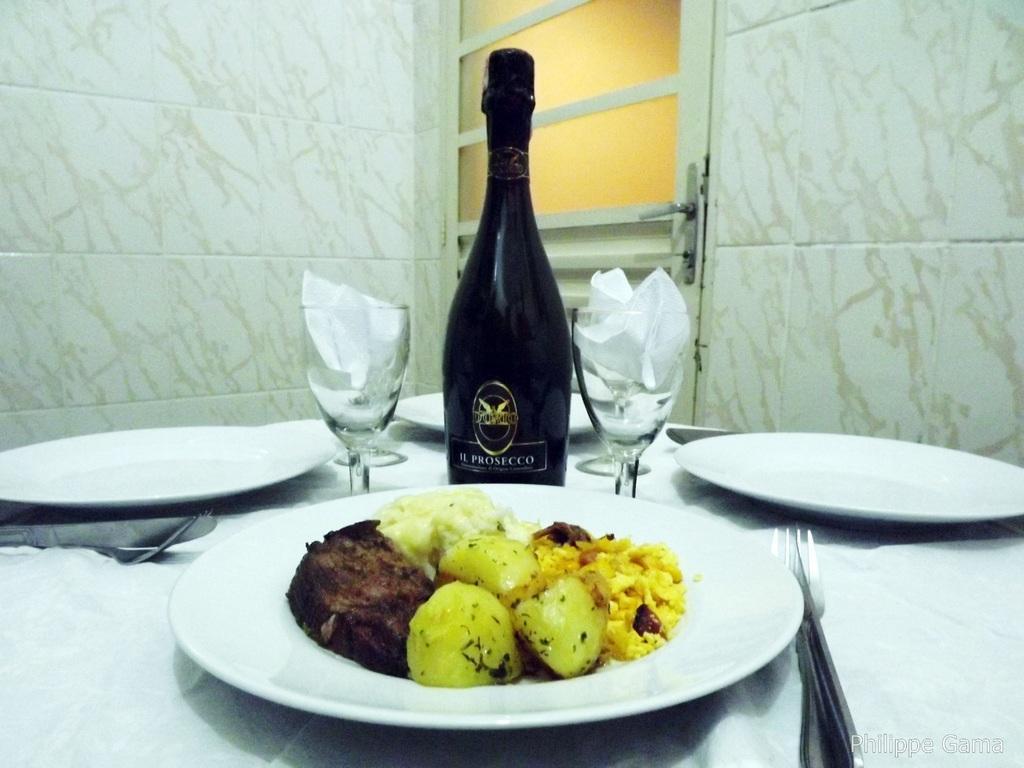Describe this image in one or two sentences. In this image there is a table on that table there are plants, in one plate there is food item and there are glasses and a champagne bottle, forks, in the background there is a wall to that wall there is a door. 